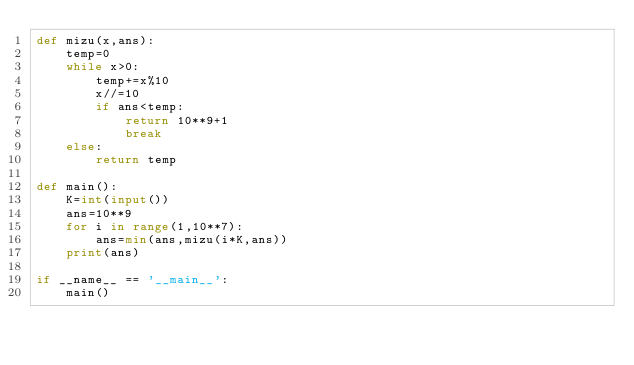Convert code to text. <code><loc_0><loc_0><loc_500><loc_500><_Python_>def mizu(x,ans):
    temp=0
    while x>0:
        temp+=x%10
        x//=10
        if ans<temp:
            return 10**9+1
            break
    else:
        return temp 

def main():
    K=int(input())
    ans=10**9
    for i in range(1,10**7):
        ans=min(ans,mizu(i*K,ans))
    print(ans)

if __name__ == '__main__':
    main()</code> 